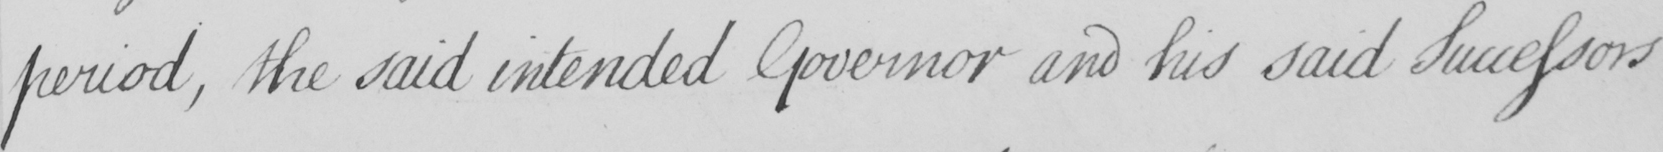Please transcribe the handwritten text in this image. period , the said intended Governor and his said Successors 